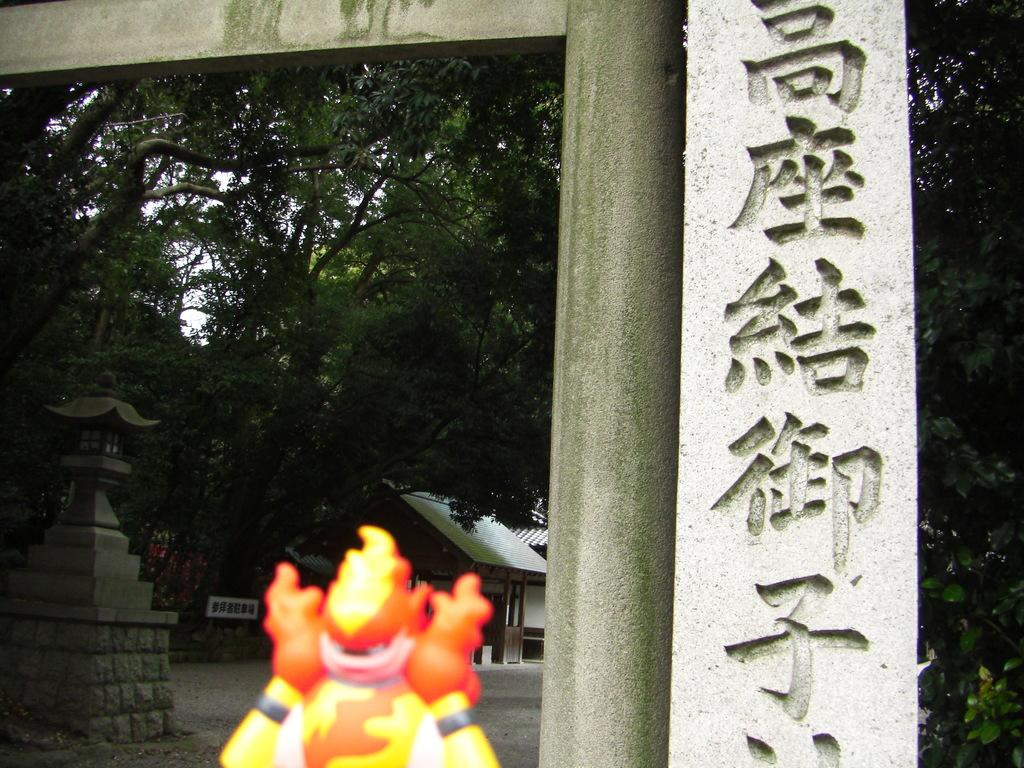What type of natural elements are present in the image? There are many trees in the image. What man-made structure can be seen in the image? There is a stone pillar in the image. Can you describe the colors of any objects in the image? There is an object with colors of orange, yellow, and white in the image. What type of drug is being sold by the man in the image? There is no man or drug present in the image; it features trees and a stone pillar. 